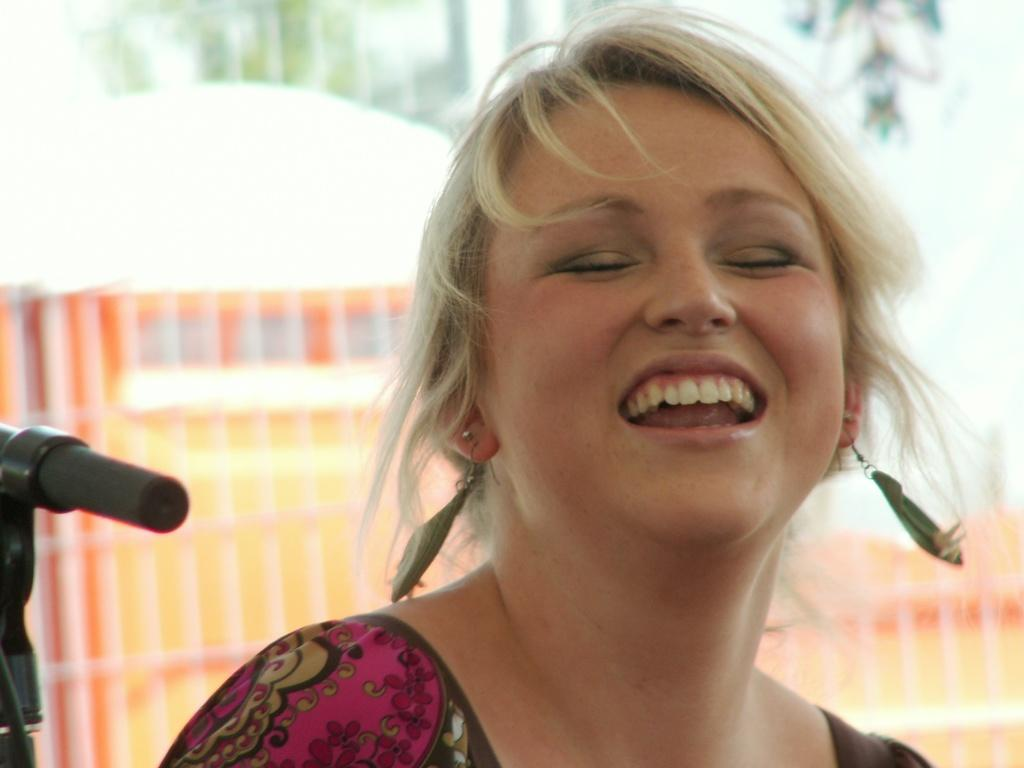Who is present in the image? There is a woman in the image. What is the woman's expression? The woman is smiling. Can you describe the background of the image? The background of the image is blurred. What object can be seen on the left side of the image? There is a mic on the left side of the image. What type of square object is the woman holding in the image? There is no square object present in the image. 